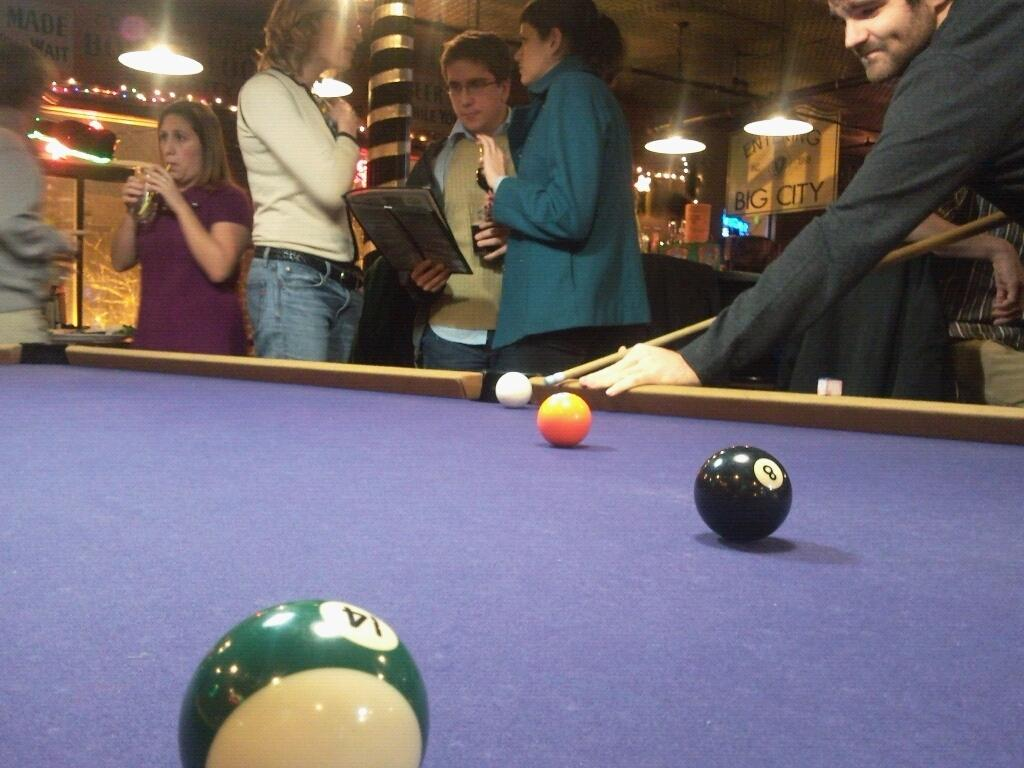How many people are in the image? There is a group of people in the image, but the exact number is not specified. What are the people doing in the image? The people are standing on the floor. What is the main object in the image besides the people? There is a snooker table in the image. What is on the snooker table? The snooker table has balls on it. How many bikes are parked near the snooker table in the image? There is no mention of bikes in the image, so we cannot determine how many there might be. 